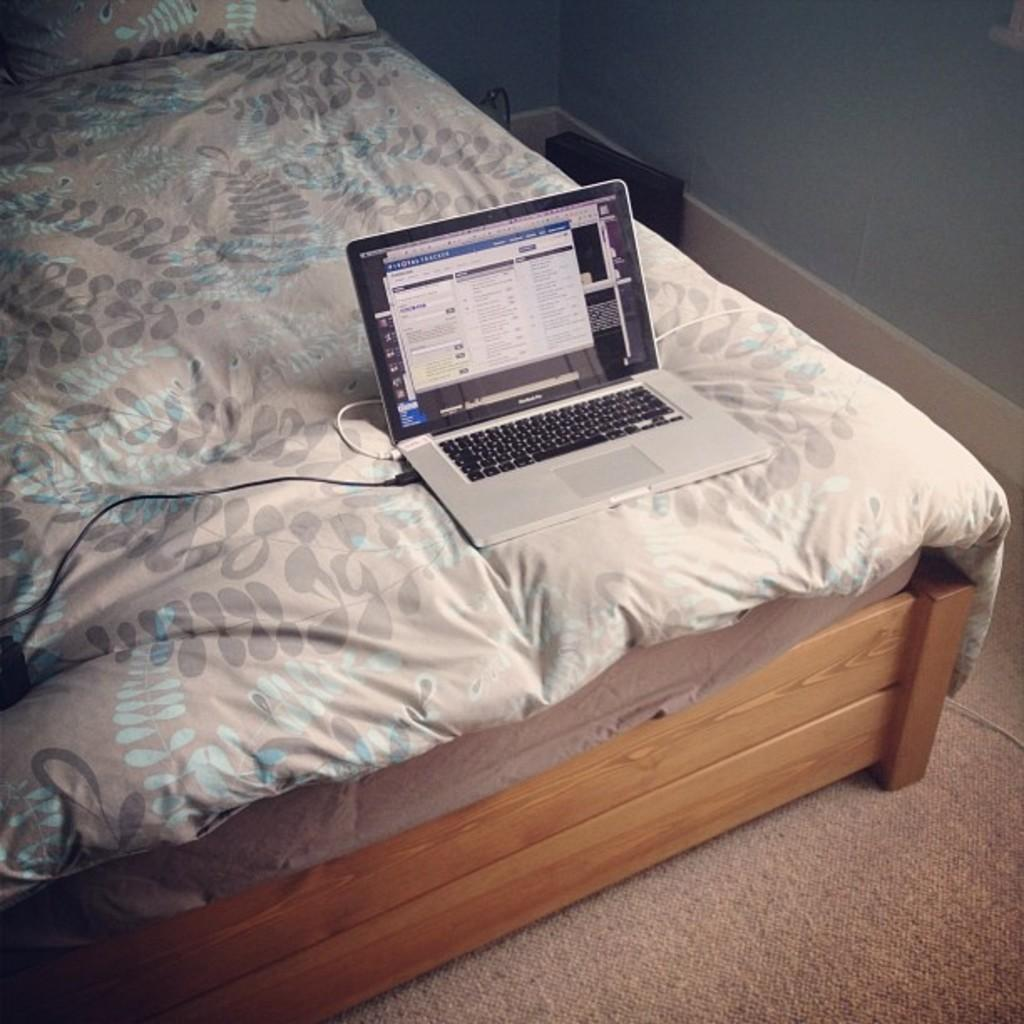What electronic device is visible in the image? There is a laptop with wires in the image. Where is the laptop located? The laptop is on a bed. What type of furniture is the bed placed on? The bed is on a cot. What can be seen in the background of the image? There is a wall in the background of the image. What type of flooring is present in the room? There is a carpet on the floor. What grade did the daughter receive on her last exam, as shown in the image? There is no mention of a daughter or an exam in the image; it features a laptop with wires on a bed. How many trees are visible in the image? There are no trees visible in the image; it shows a laptop on a bed in a room with a wall and carpeted floor. 